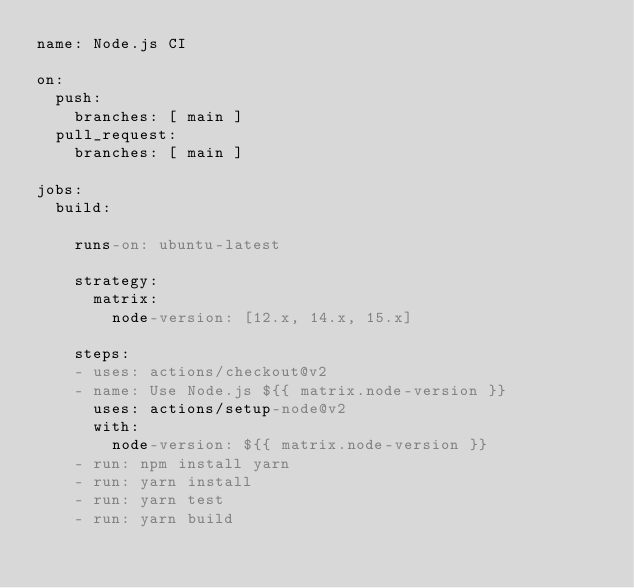Convert code to text. <code><loc_0><loc_0><loc_500><loc_500><_YAML_>name: Node.js CI

on:
  push:
    branches: [ main ]
  pull_request:
    branches: [ main ]

jobs:
  build:

    runs-on: ubuntu-latest

    strategy:
      matrix:
        node-version: [12.x, 14.x, 15.x]

    steps:
    - uses: actions/checkout@v2
    - name: Use Node.js ${{ matrix.node-version }}
      uses: actions/setup-node@v2
      with:
        node-version: ${{ matrix.node-version }}
    - run: npm install yarn
    - run: yarn install
    - run: yarn test
    - run: yarn build
</code> 